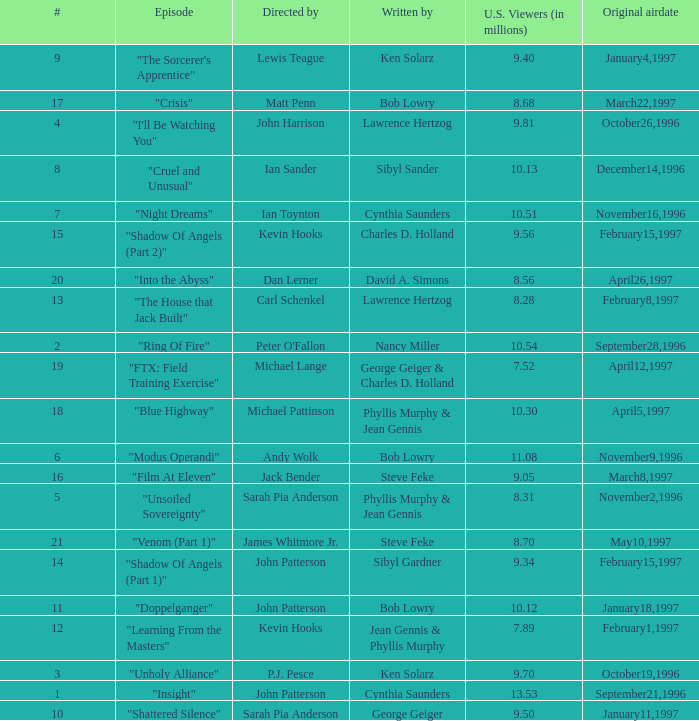What are the titles of episodes numbered 19? "FTX: Field Training Exercise". 